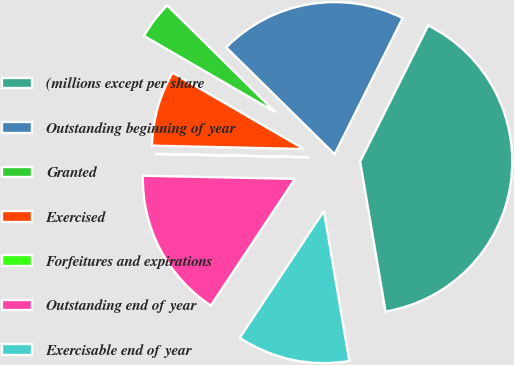Convert chart to OTSL. <chart><loc_0><loc_0><loc_500><loc_500><pie_chart><fcel>(millions except per share<fcel>Outstanding beginning of year<fcel>Granted<fcel>Exercised<fcel>Forfeitures and expirations<fcel>Outstanding end of year<fcel>Exercisable end of year<nl><fcel>39.95%<fcel>19.99%<fcel>4.02%<fcel>8.01%<fcel>0.03%<fcel>16.0%<fcel>12.0%<nl></chart> 